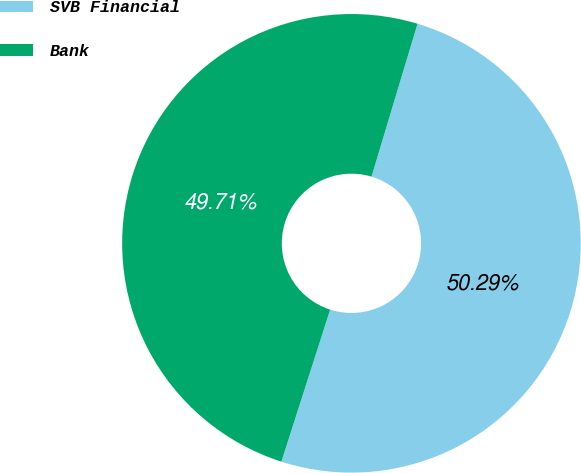Convert chart. <chart><loc_0><loc_0><loc_500><loc_500><pie_chart><fcel>SVB Financial<fcel>Bank<nl><fcel>50.29%<fcel>49.71%<nl></chart> 